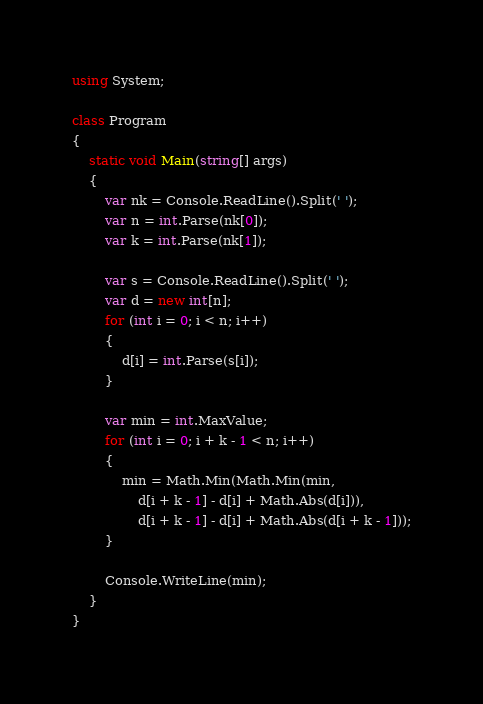<code> <loc_0><loc_0><loc_500><loc_500><_C#_>using System;

class Program
{
    static void Main(string[] args)
    {
        var nk = Console.ReadLine().Split(' ');
        var n = int.Parse(nk[0]);
        var k = int.Parse(nk[1]);

        var s = Console.ReadLine().Split(' ');
        var d = new int[n];
        for (int i = 0; i < n; i++)
        {
            d[i] = int.Parse(s[i]);
        }

        var min = int.MaxValue;
        for (int i = 0; i + k - 1 < n; i++)
        {
            min = Math.Min(Math.Min(min,
                d[i + k - 1] - d[i] + Math.Abs(d[i])),
                d[i + k - 1] - d[i] + Math.Abs(d[i + k - 1]));
        }

        Console.WriteLine(min);
    }
}</code> 